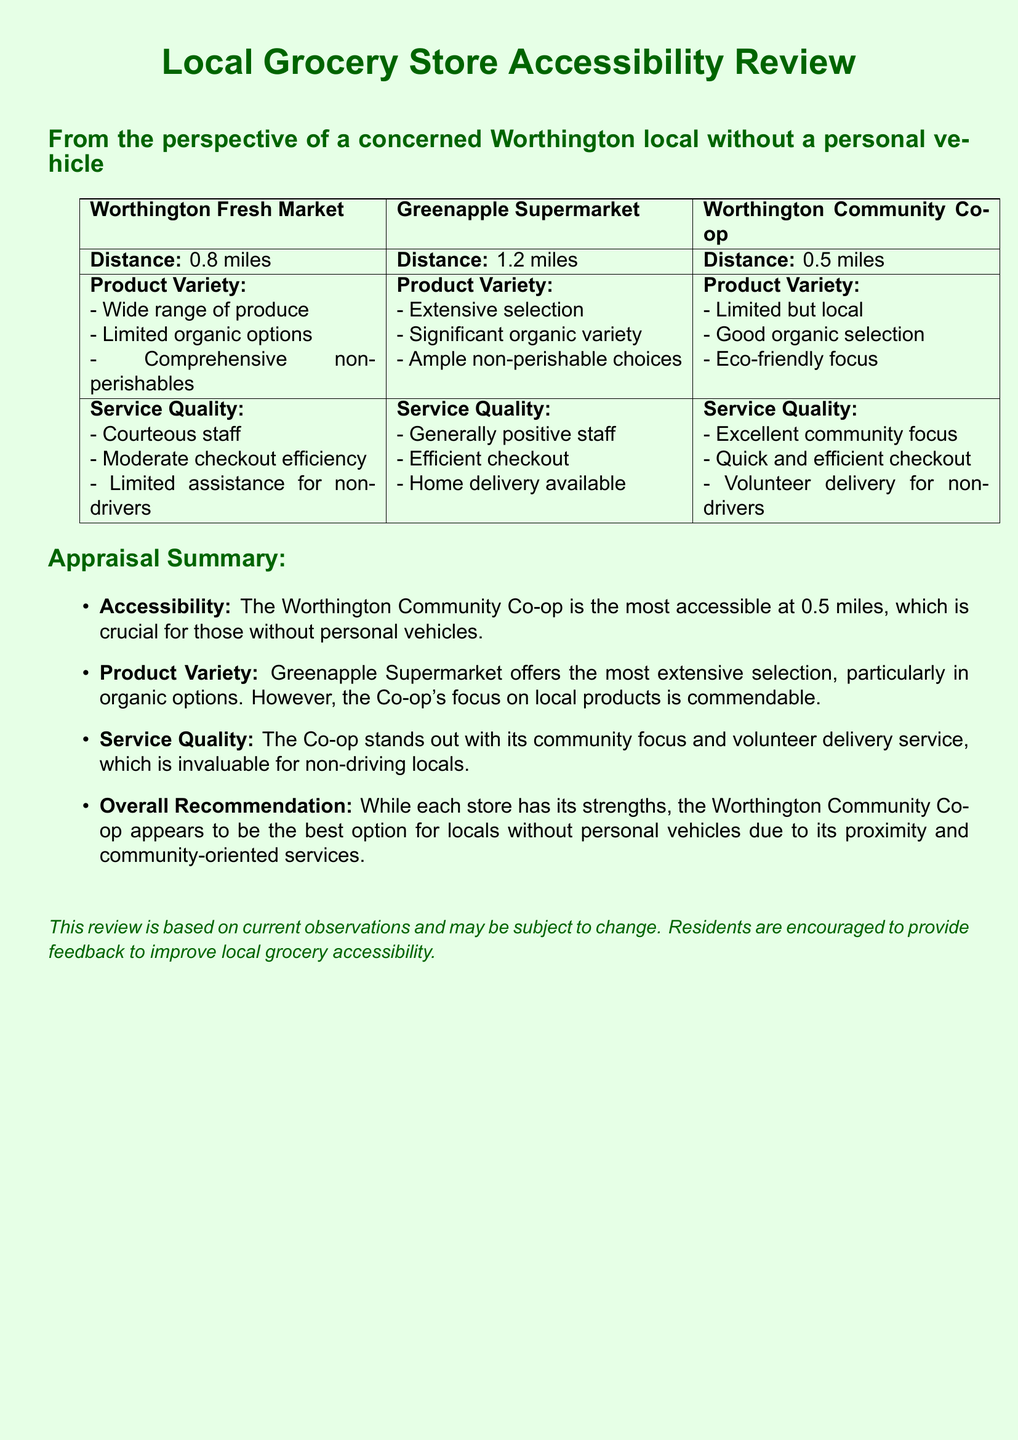What is the distance to Worthington Fresh Market? The distance is explicitly stated in the document under the grocery store section.
Answer: 0.8 miles What type of delivery service is available at Greenapple Supermarket? The document mentions the services offered at Greenapple Supermarket, including home delivery, which is relevant to non-drivers.
Answer: Home delivery Which grocery store has the shortest distance? The distances listed for each store allow for a comparative analysis.
Answer: Worthington Community Co-op What kind of product variety does Worthington Community Co-op offer? The document describes the product variety available at each store, emphasizing local options at the Co-op.
Answer: Limited but local Which grocery store is recommended for locals without personal vehicles? The summary section provides an overall recommendation based on accessibility, product variety, and service quality.
Answer: Worthington Community Co-op What is the primary focus of the Worthington Community Co-op's product selection? The document outlines the focus areas of each store's product selection, highlighting the community aspect for the Co-op.
Answer: Eco-friendly focus How efficient is the checkout process at Worthington Fresh Market? The service quality section includes specific evaluations of checkout efficiency for each market.
Answer: Moderate checkout efficiency What unique service does Worthington Community Co-op provide for non-drivers? The document specifies certain services provided by the Co-op aimed at assisting non-drivers in the community.
Answer: Volunteer delivery 